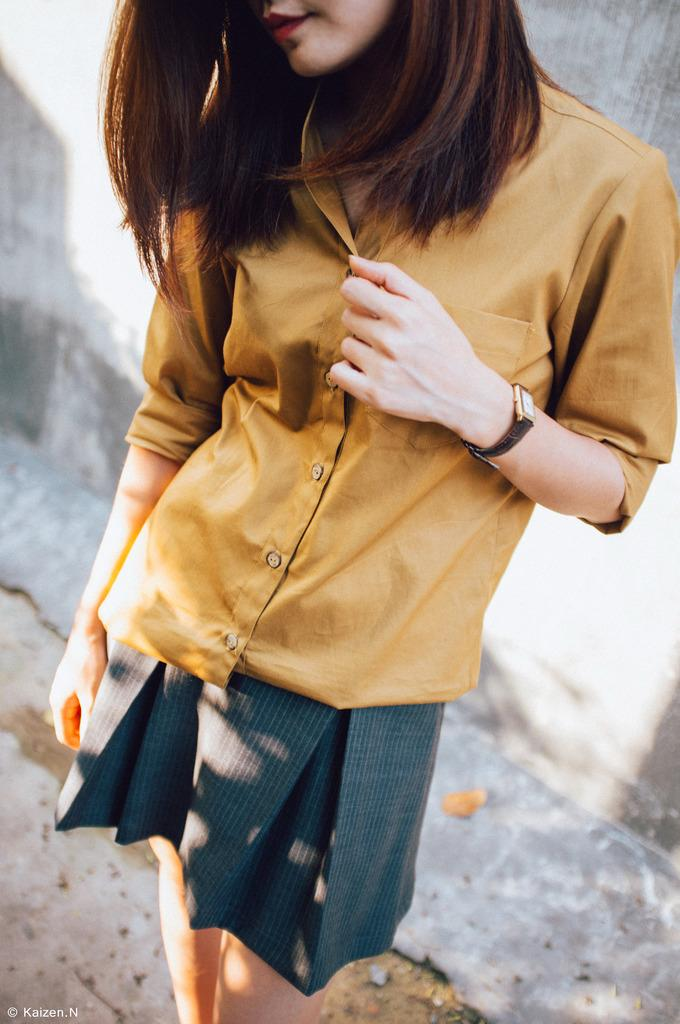Who is present in the image? There is a woman in the image. What is the woman's position in relation to the ground? The woman is standing on the ground. What can be seen in the background of the image? There is a wall in the background of the image. What type of thrill can be seen on the woman's face in the image? There is no indication of a thrill or any specific emotion on the woman's face in the image. What list is the woman holding in the image? There is no list present in the image. 